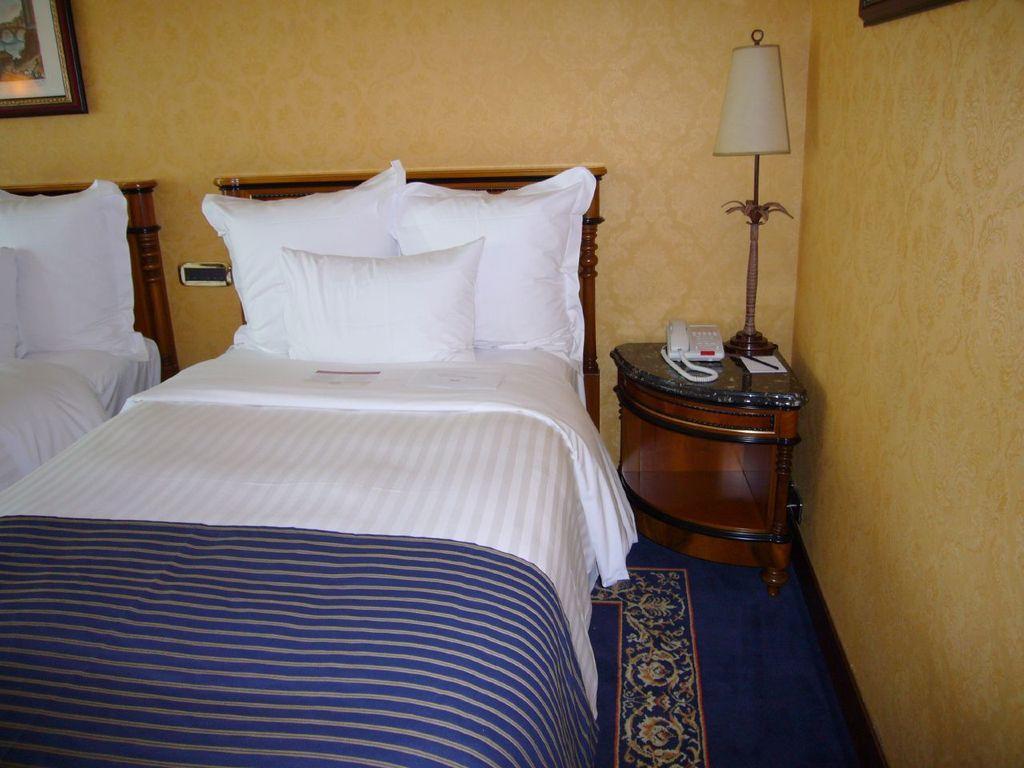Please provide a concise description of this image. The room consists of two bed. On the bed there is white bed cover , pillows. On the floor there is a blue carpet. Beside the bed there is a side table. On it there is lamp, phone. The wall is yellow in color. On the top left there is a portrait on the wall. 